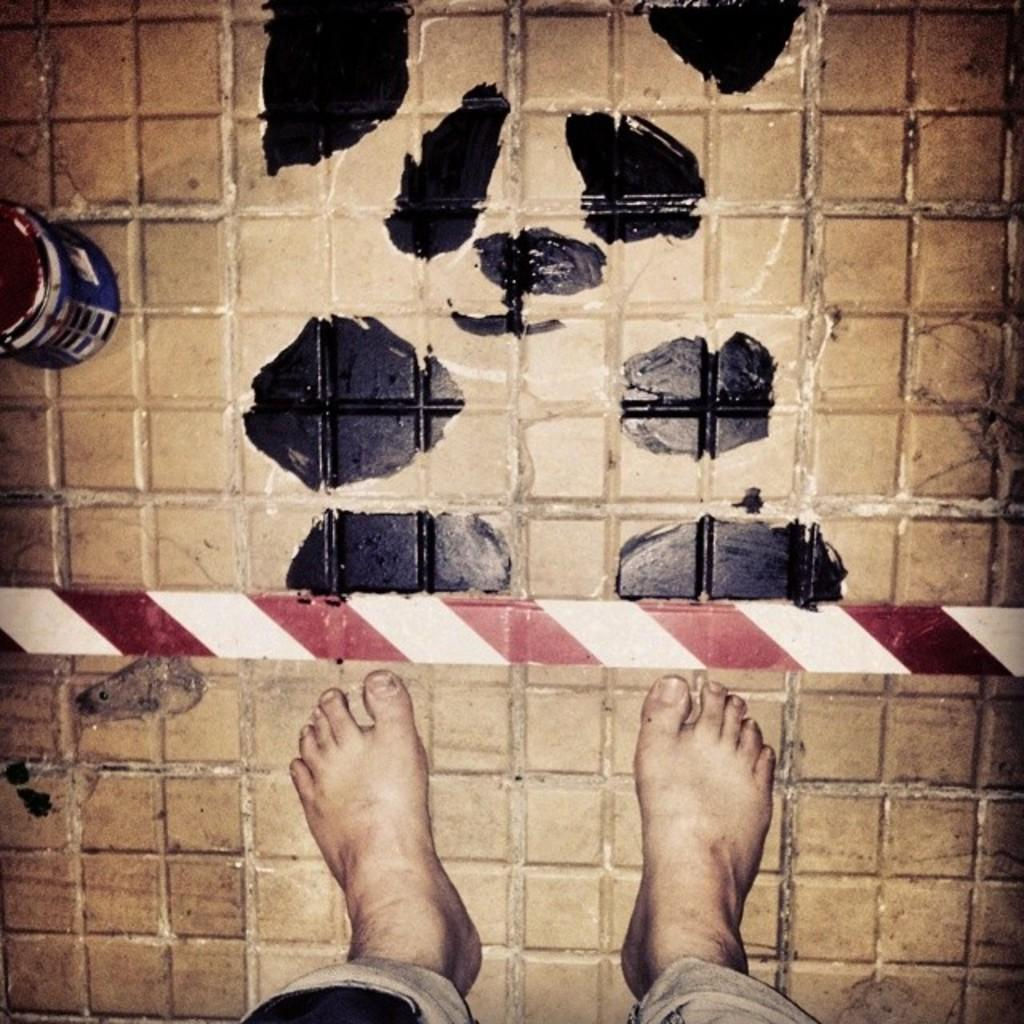What is present in the image? There is a person in the image. Which part of the person's body is visible in the image? The person's legs are visible in the image. What is the color of the floor in the image? The floor in the image has brown and black colors. What type of cabbage is being used as fuel for the party in the image? There is no cabbage, fuel, or party present in the image. What type of party is being held in the image? There is no party present in the image. 